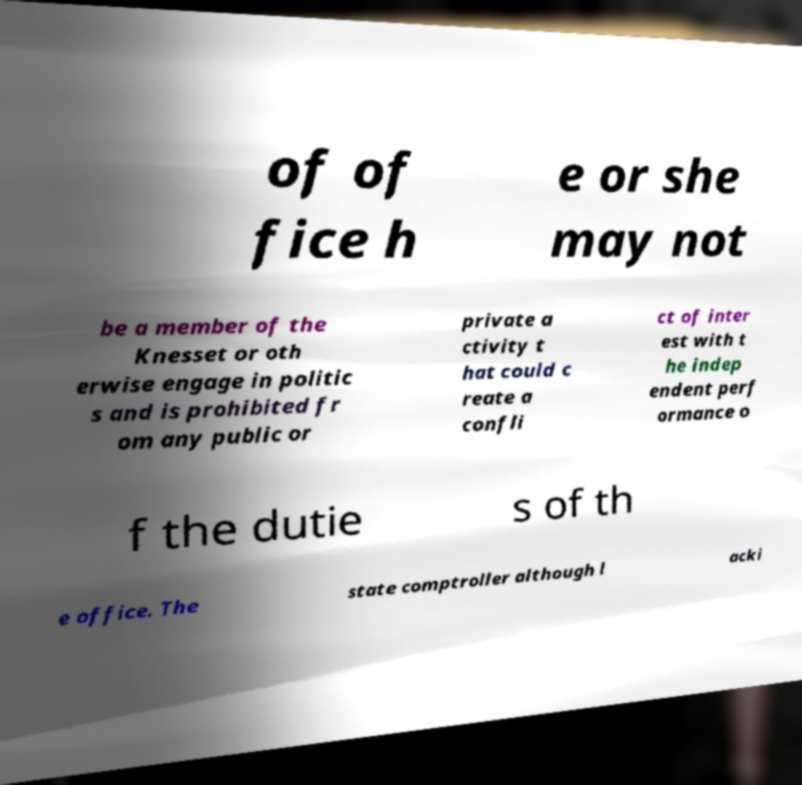I need the written content from this picture converted into text. Can you do that? of of fice h e or she may not be a member of the Knesset or oth erwise engage in politic s and is prohibited fr om any public or private a ctivity t hat could c reate a confli ct of inter est with t he indep endent perf ormance o f the dutie s of th e office. The state comptroller although l acki 